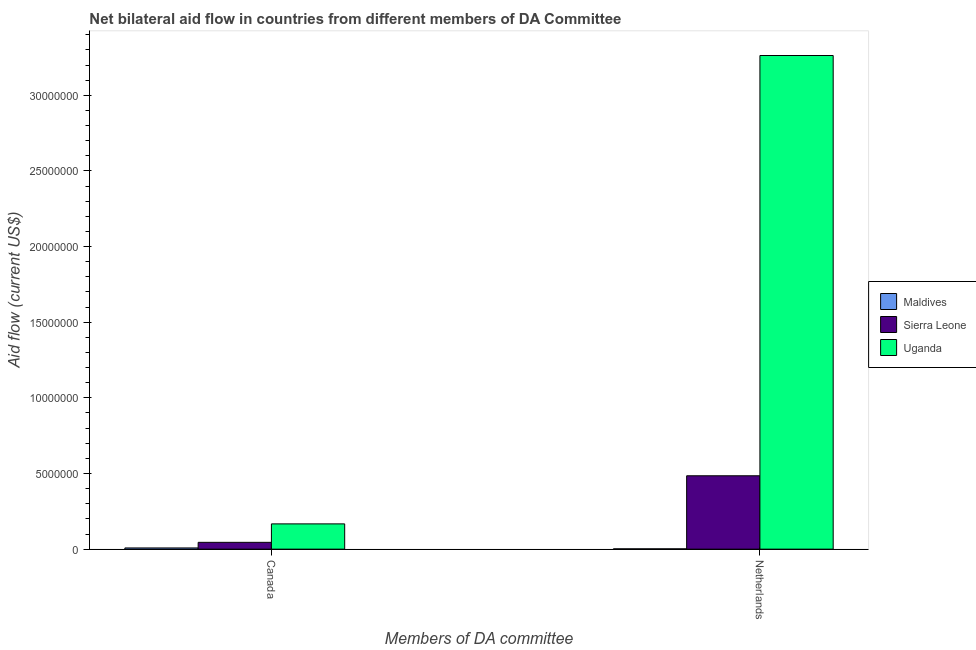How many different coloured bars are there?
Provide a short and direct response. 3. Are the number of bars per tick equal to the number of legend labels?
Your response must be concise. Yes. How many bars are there on the 1st tick from the right?
Offer a very short reply. 3. What is the amount of aid given by canada in Uganda?
Provide a short and direct response. 1.67e+06. Across all countries, what is the maximum amount of aid given by canada?
Make the answer very short. 1.67e+06. Across all countries, what is the minimum amount of aid given by canada?
Keep it short and to the point. 8.00e+04. In which country was the amount of aid given by canada maximum?
Provide a succinct answer. Uganda. In which country was the amount of aid given by netherlands minimum?
Your answer should be very brief. Maldives. What is the total amount of aid given by canada in the graph?
Make the answer very short. 2.20e+06. What is the difference between the amount of aid given by netherlands in Uganda and that in Maldives?
Your response must be concise. 3.26e+07. What is the difference between the amount of aid given by canada in Maldives and the amount of aid given by netherlands in Uganda?
Give a very brief answer. -3.26e+07. What is the average amount of aid given by netherlands per country?
Your response must be concise. 1.25e+07. What is the difference between the amount of aid given by canada and amount of aid given by netherlands in Uganda?
Give a very brief answer. -3.10e+07. In how many countries, is the amount of aid given by netherlands greater than 6000000 US$?
Offer a very short reply. 1. What is the ratio of the amount of aid given by canada in Sierra Leone to that in Maldives?
Give a very brief answer. 5.62. Is the amount of aid given by netherlands in Sierra Leone less than that in Maldives?
Provide a succinct answer. No. What does the 2nd bar from the left in Canada represents?
Provide a short and direct response. Sierra Leone. What does the 1st bar from the right in Canada represents?
Offer a terse response. Uganda. How many bars are there?
Keep it short and to the point. 6. Are all the bars in the graph horizontal?
Provide a short and direct response. No. Does the graph contain grids?
Give a very brief answer. No. How many legend labels are there?
Give a very brief answer. 3. How are the legend labels stacked?
Provide a short and direct response. Vertical. What is the title of the graph?
Your answer should be compact. Net bilateral aid flow in countries from different members of DA Committee. Does "Macao" appear as one of the legend labels in the graph?
Make the answer very short. No. What is the label or title of the X-axis?
Provide a succinct answer. Members of DA committee. What is the Aid flow (current US$) in Maldives in Canada?
Your answer should be compact. 8.00e+04. What is the Aid flow (current US$) in Uganda in Canada?
Provide a succinct answer. 1.67e+06. What is the Aid flow (current US$) in Maldives in Netherlands?
Provide a succinct answer. 2.00e+04. What is the Aid flow (current US$) in Sierra Leone in Netherlands?
Ensure brevity in your answer.  4.85e+06. What is the Aid flow (current US$) of Uganda in Netherlands?
Keep it short and to the point. 3.26e+07. Across all Members of DA committee, what is the maximum Aid flow (current US$) of Sierra Leone?
Make the answer very short. 4.85e+06. Across all Members of DA committee, what is the maximum Aid flow (current US$) of Uganda?
Your answer should be compact. 3.26e+07. Across all Members of DA committee, what is the minimum Aid flow (current US$) in Maldives?
Offer a very short reply. 2.00e+04. Across all Members of DA committee, what is the minimum Aid flow (current US$) in Uganda?
Your answer should be compact. 1.67e+06. What is the total Aid flow (current US$) of Maldives in the graph?
Provide a short and direct response. 1.00e+05. What is the total Aid flow (current US$) of Sierra Leone in the graph?
Give a very brief answer. 5.30e+06. What is the total Aid flow (current US$) in Uganda in the graph?
Provide a succinct answer. 3.43e+07. What is the difference between the Aid flow (current US$) in Maldives in Canada and that in Netherlands?
Your answer should be compact. 6.00e+04. What is the difference between the Aid flow (current US$) in Sierra Leone in Canada and that in Netherlands?
Offer a very short reply. -4.40e+06. What is the difference between the Aid flow (current US$) in Uganda in Canada and that in Netherlands?
Your answer should be compact. -3.10e+07. What is the difference between the Aid flow (current US$) in Maldives in Canada and the Aid flow (current US$) in Sierra Leone in Netherlands?
Your answer should be very brief. -4.77e+06. What is the difference between the Aid flow (current US$) in Maldives in Canada and the Aid flow (current US$) in Uganda in Netherlands?
Offer a very short reply. -3.26e+07. What is the difference between the Aid flow (current US$) in Sierra Leone in Canada and the Aid flow (current US$) in Uganda in Netherlands?
Provide a succinct answer. -3.22e+07. What is the average Aid flow (current US$) of Maldives per Members of DA committee?
Your answer should be very brief. 5.00e+04. What is the average Aid flow (current US$) of Sierra Leone per Members of DA committee?
Ensure brevity in your answer.  2.65e+06. What is the average Aid flow (current US$) of Uganda per Members of DA committee?
Ensure brevity in your answer.  1.72e+07. What is the difference between the Aid flow (current US$) in Maldives and Aid flow (current US$) in Sierra Leone in Canada?
Your answer should be very brief. -3.70e+05. What is the difference between the Aid flow (current US$) of Maldives and Aid flow (current US$) of Uganda in Canada?
Offer a terse response. -1.59e+06. What is the difference between the Aid flow (current US$) of Sierra Leone and Aid flow (current US$) of Uganda in Canada?
Ensure brevity in your answer.  -1.22e+06. What is the difference between the Aid flow (current US$) in Maldives and Aid flow (current US$) in Sierra Leone in Netherlands?
Offer a terse response. -4.83e+06. What is the difference between the Aid flow (current US$) in Maldives and Aid flow (current US$) in Uganda in Netherlands?
Provide a succinct answer. -3.26e+07. What is the difference between the Aid flow (current US$) of Sierra Leone and Aid flow (current US$) of Uganda in Netherlands?
Offer a terse response. -2.78e+07. What is the ratio of the Aid flow (current US$) in Sierra Leone in Canada to that in Netherlands?
Provide a short and direct response. 0.09. What is the ratio of the Aid flow (current US$) of Uganda in Canada to that in Netherlands?
Offer a very short reply. 0.05. What is the difference between the highest and the second highest Aid flow (current US$) in Sierra Leone?
Keep it short and to the point. 4.40e+06. What is the difference between the highest and the second highest Aid flow (current US$) in Uganda?
Offer a terse response. 3.10e+07. What is the difference between the highest and the lowest Aid flow (current US$) in Sierra Leone?
Make the answer very short. 4.40e+06. What is the difference between the highest and the lowest Aid flow (current US$) of Uganda?
Ensure brevity in your answer.  3.10e+07. 